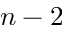Convert formula to latex. <formula><loc_0><loc_0><loc_500><loc_500>n - 2</formula> 